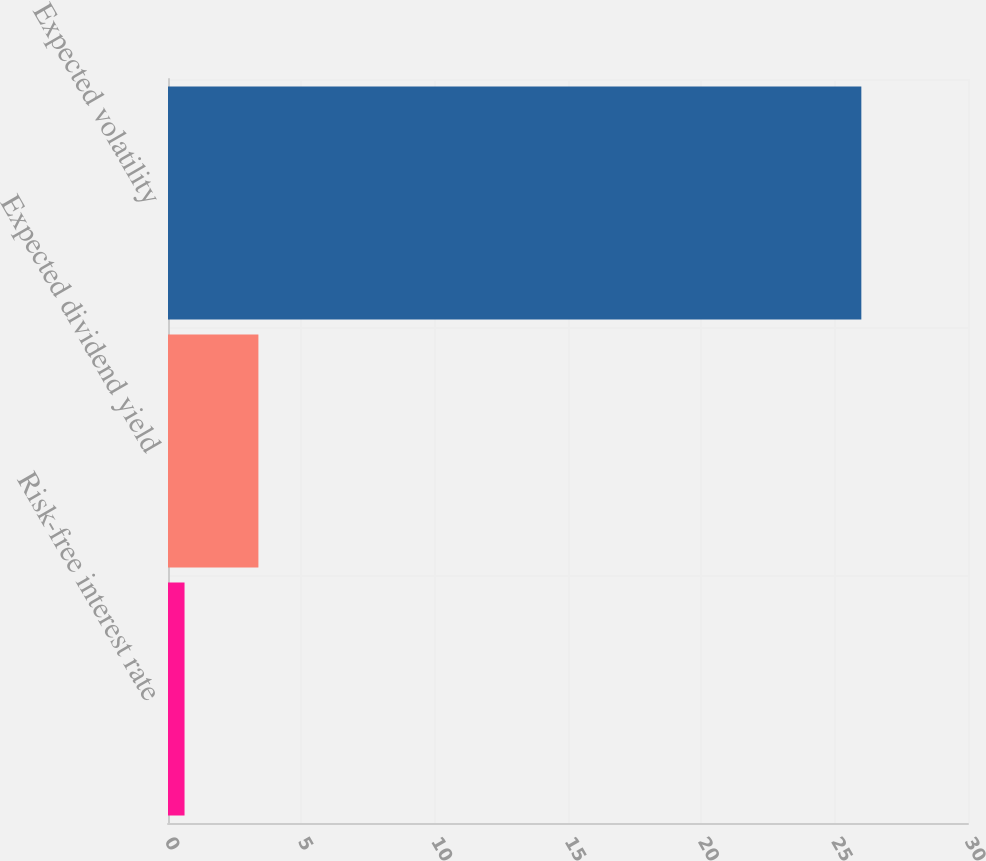<chart> <loc_0><loc_0><loc_500><loc_500><bar_chart><fcel>Risk-free interest rate<fcel>Expected dividend yield<fcel>Expected volatility<nl><fcel>0.62<fcel>3.39<fcel>26<nl></chart> 